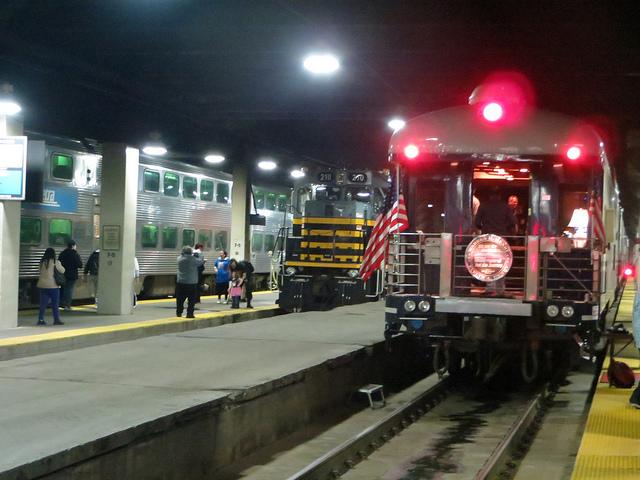Is that an american flag?
Answer briefly. Yes. Is this train station full of people?
Be succinct. Yes. Are there any people on the platform?
Concise answer only. Yes. Was the picture taken outside?
Quick response, please. Yes. Is this in the US?
Keep it brief. Yes. How many red lights are there?
Concise answer only. 3. How many people are in the front of the train?
Give a very brief answer. 0. 